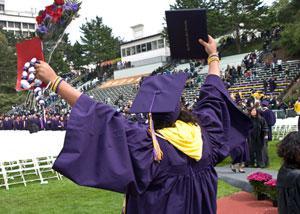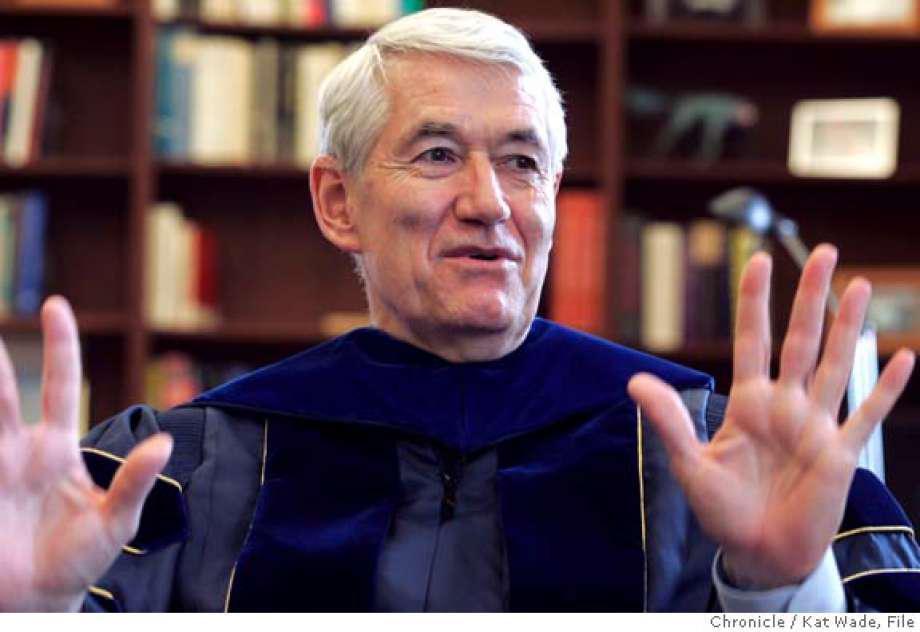The first image is the image on the left, the second image is the image on the right. For the images shown, is this caption "No more than two people in graduation robes can be seen in either picture." true? Answer yes or no. No. The first image is the image on the left, the second image is the image on the right. Assess this claim about the two images: "One image features a single graduate in the foreground raising at least one hand in the air, and wearing a royal purple robe with yellow around the neck and a hat with a tassle.". Correct or not? Answer yes or no. Yes. 